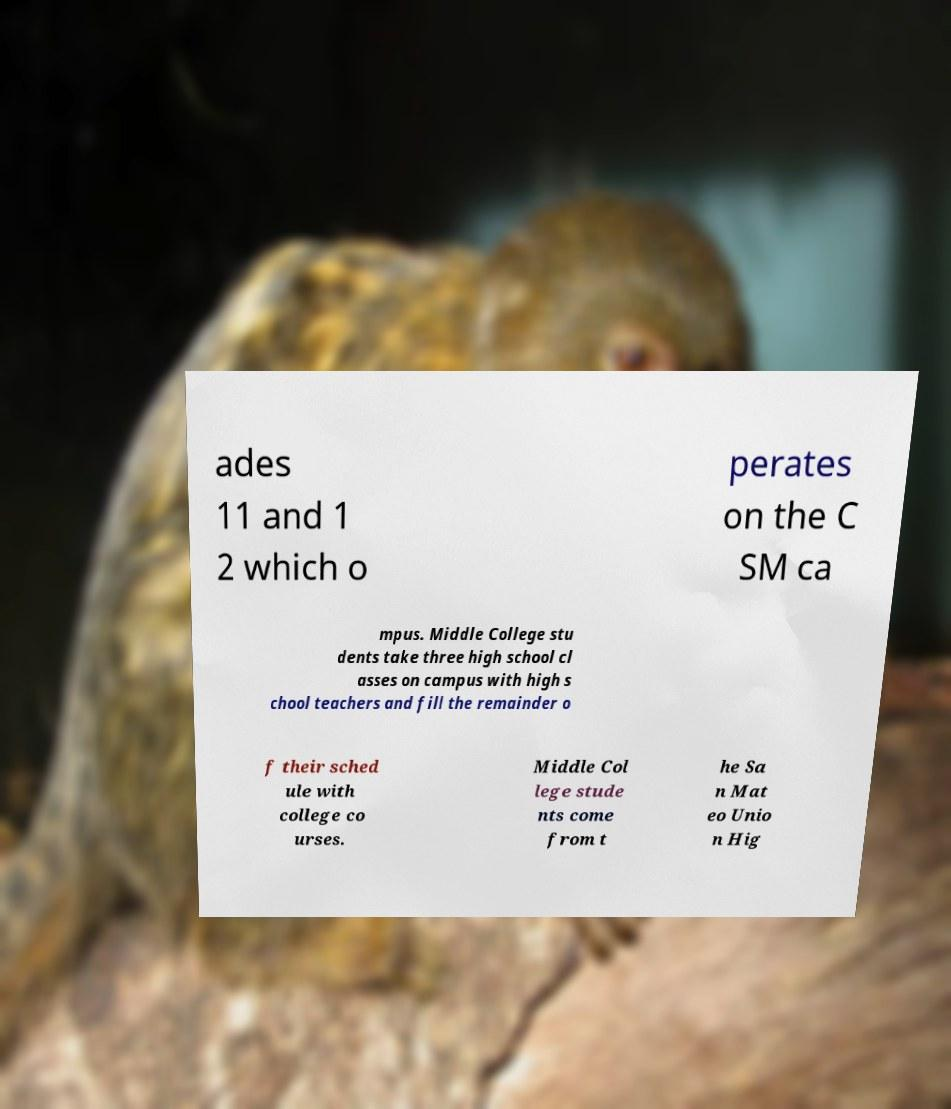There's text embedded in this image that I need extracted. Can you transcribe it verbatim? ades 11 and 1 2 which o perates on the C SM ca mpus. Middle College stu dents take three high school cl asses on campus with high s chool teachers and fill the remainder o f their sched ule with college co urses. Middle Col lege stude nts come from t he Sa n Mat eo Unio n Hig 